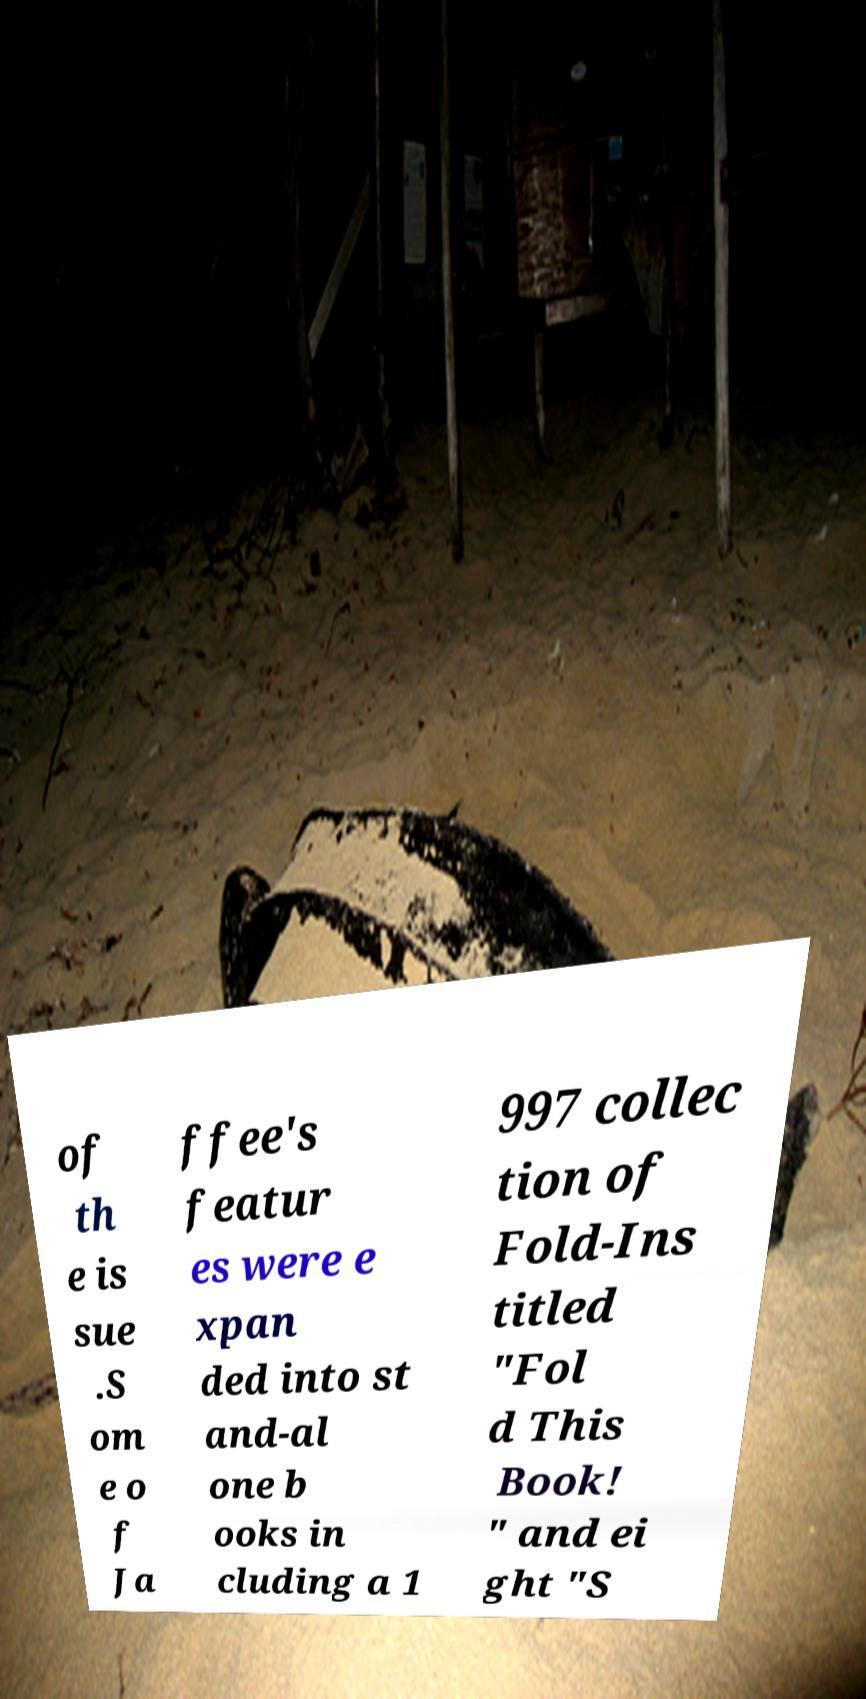There's text embedded in this image that I need extracted. Can you transcribe it verbatim? of th e is sue .S om e o f Ja ffee's featur es were e xpan ded into st and-al one b ooks in cluding a 1 997 collec tion of Fold-Ins titled "Fol d This Book! " and ei ght "S 